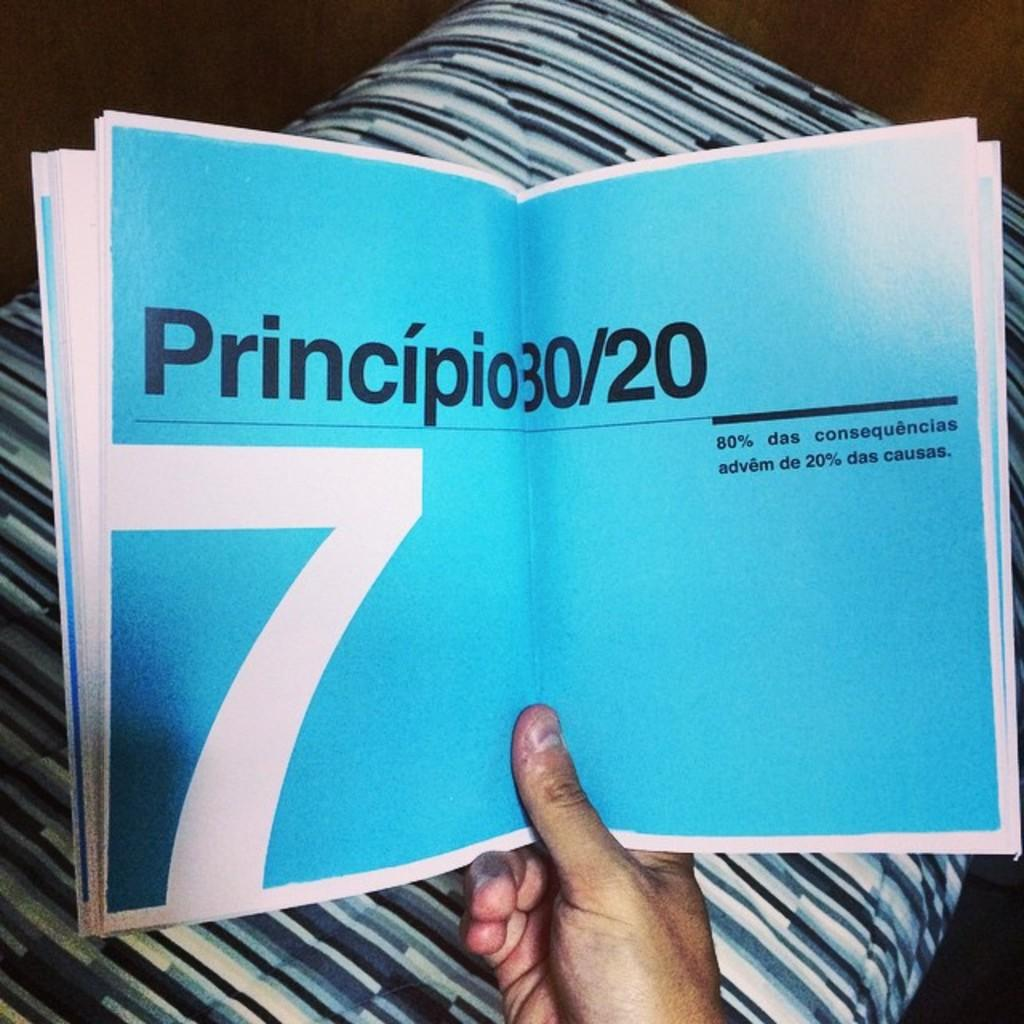<image>
Share a concise interpretation of the image provided. A booklet is open to a baby blue two page spread indicated as chapter 7. 